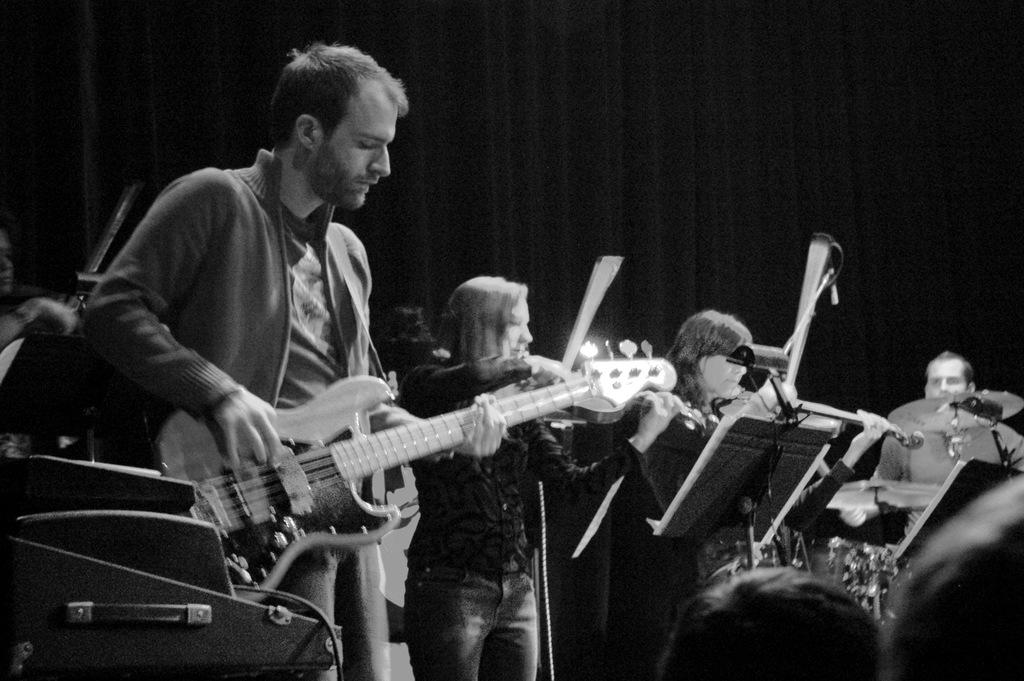Who or what is present in the image? There are people in the image. What are the people doing in the image? The people are standing and holding a guitar in their hands. Are there any other musical instruments in the image? Yes, other musical instruments are present in the image. What is the color scheme of the image? The image is in black and white color. What type of cup is being used in the image? There is no cup present in the image. 